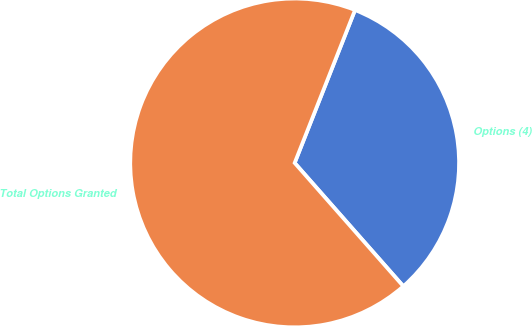<chart> <loc_0><loc_0><loc_500><loc_500><pie_chart><fcel>Options (4)<fcel>Total Options Granted<nl><fcel>32.52%<fcel>67.48%<nl></chart> 